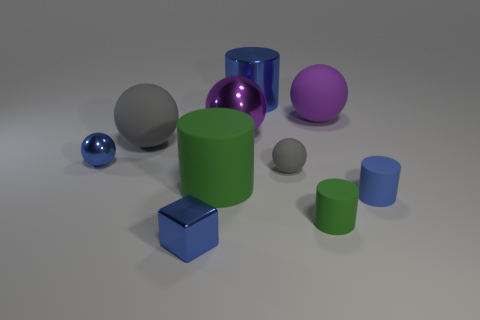Subtract 2 spheres. How many spheres are left? 3 Subtract all small shiny spheres. How many spheres are left? 4 Subtract all blue spheres. How many spheres are left? 4 Subtract all yellow spheres. Subtract all yellow cylinders. How many spheres are left? 5 Subtract all cylinders. How many objects are left? 6 Add 1 big shiny things. How many big shiny things exist? 3 Subtract 0 red blocks. How many objects are left? 10 Subtract all big gray things. Subtract all large spheres. How many objects are left? 6 Add 2 tiny balls. How many tiny balls are left? 4 